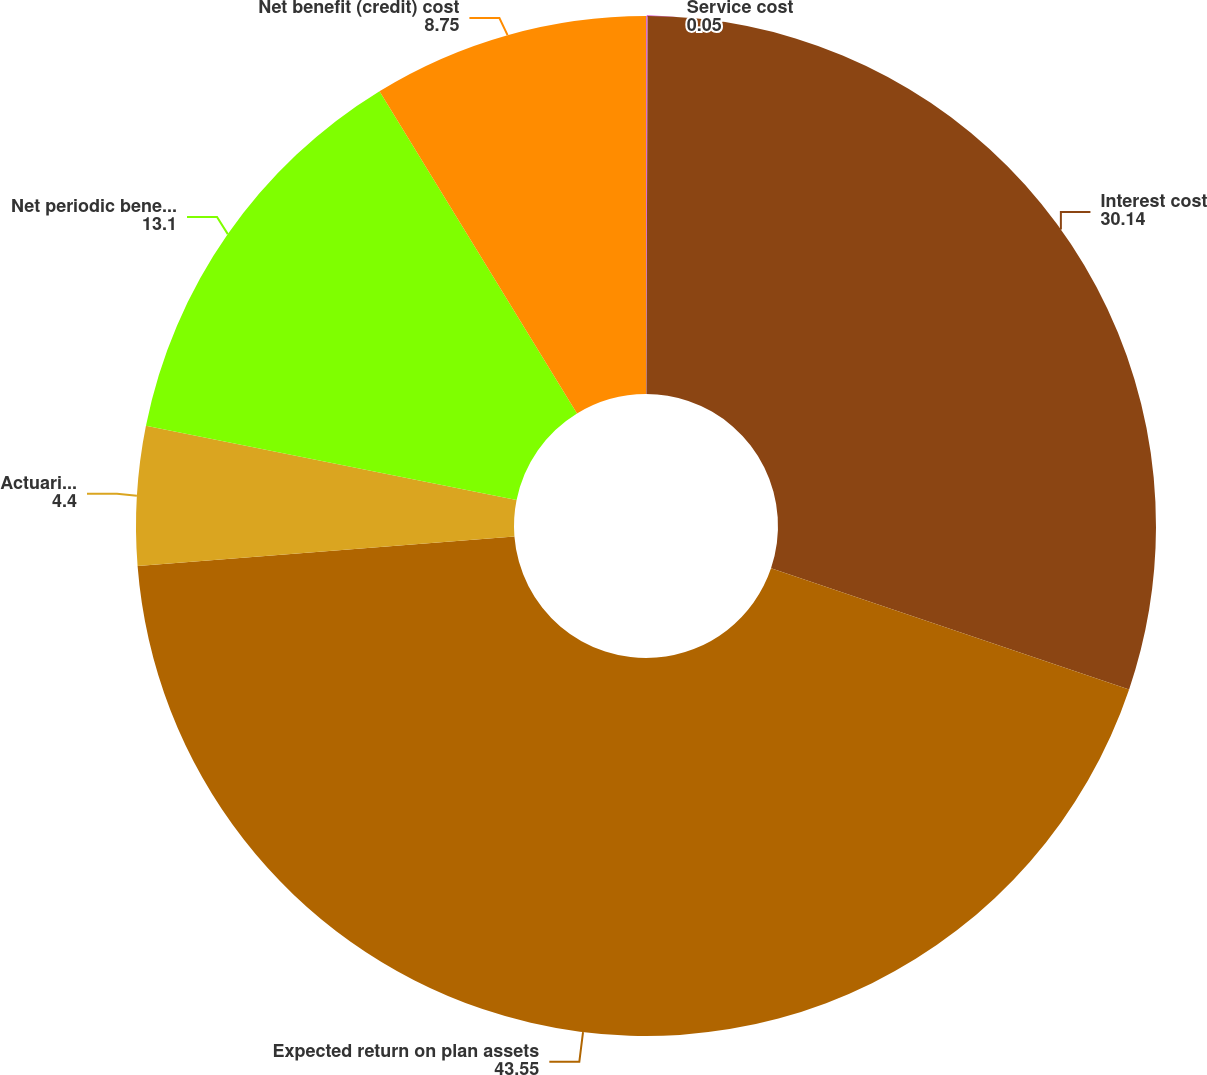<chart> <loc_0><loc_0><loc_500><loc_500><pie_chart><fcel>Service cost<fcel>Interest cost<fcel>Expected return on plan assets<fcel>Actuarial loss (gain)<fcel>Net periodic benefit (credit)<fcel>Net benefit (credit) cost<nl><fcel>0.05%<fcel>30.14%<fcel>43.55%<fcel>4.4%<fcel>13.1%<fcel>8.75%<nl></chart> 